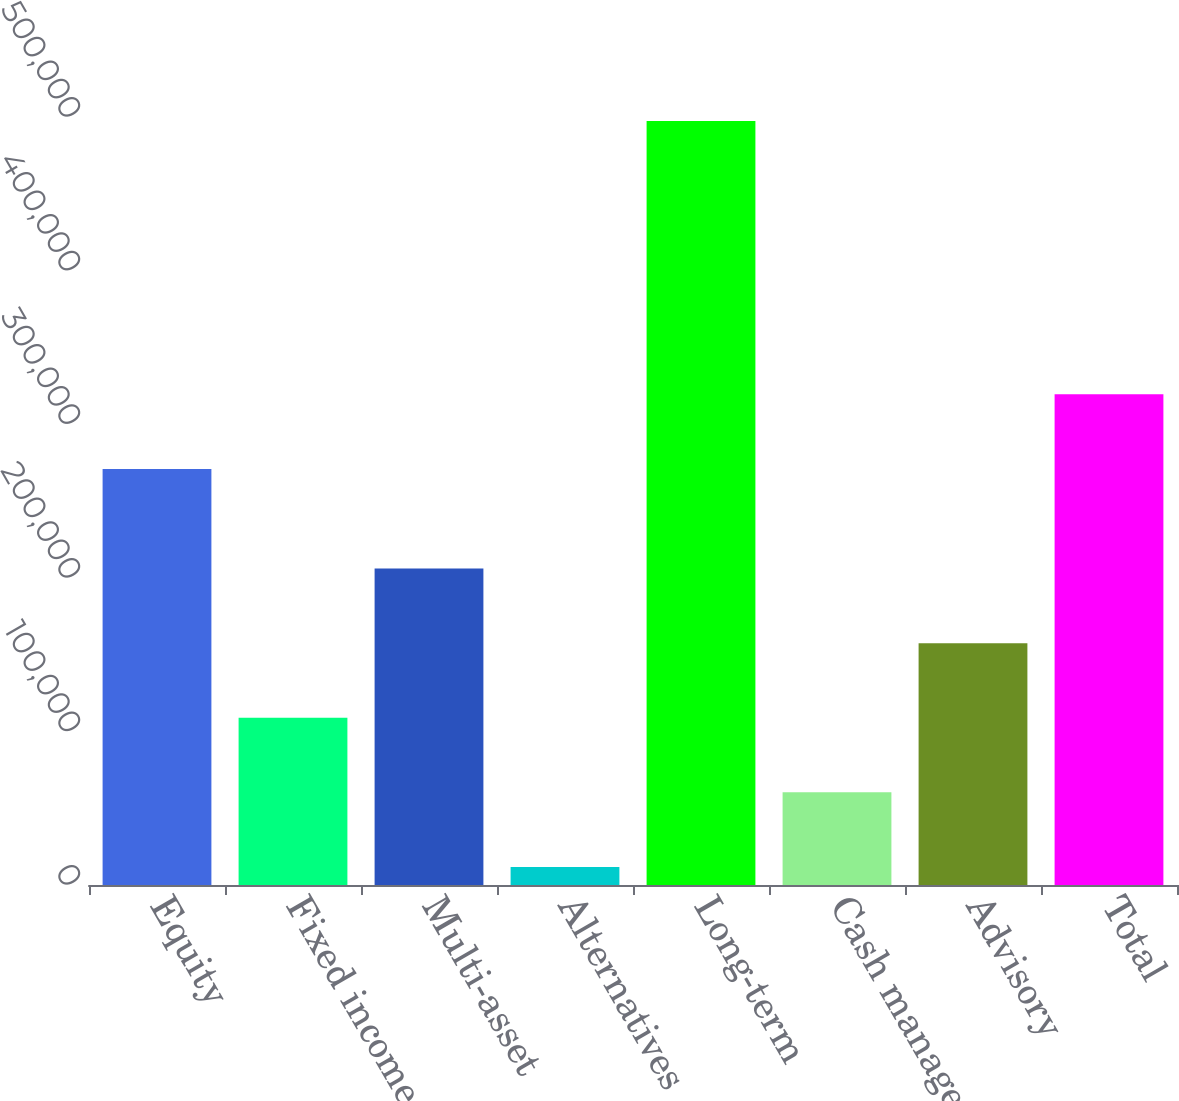Convert chart to OTSL. <chart><loc_0><loc_0><loc_500><loc_500><bar_chart><fcel>Equity<fcel>Fixed income<fcel>Multi-asset<fcel>Alternatives<fcel>Long-term<fcel>Cash management<fcel>Advisory<fcel>Total<nl><fcel>270872<fcel>108877<fcel>205995<fcel>11759<fcel>497348<fcel>60317.9<fcel>157436<fcel>319431<nl></chart> 